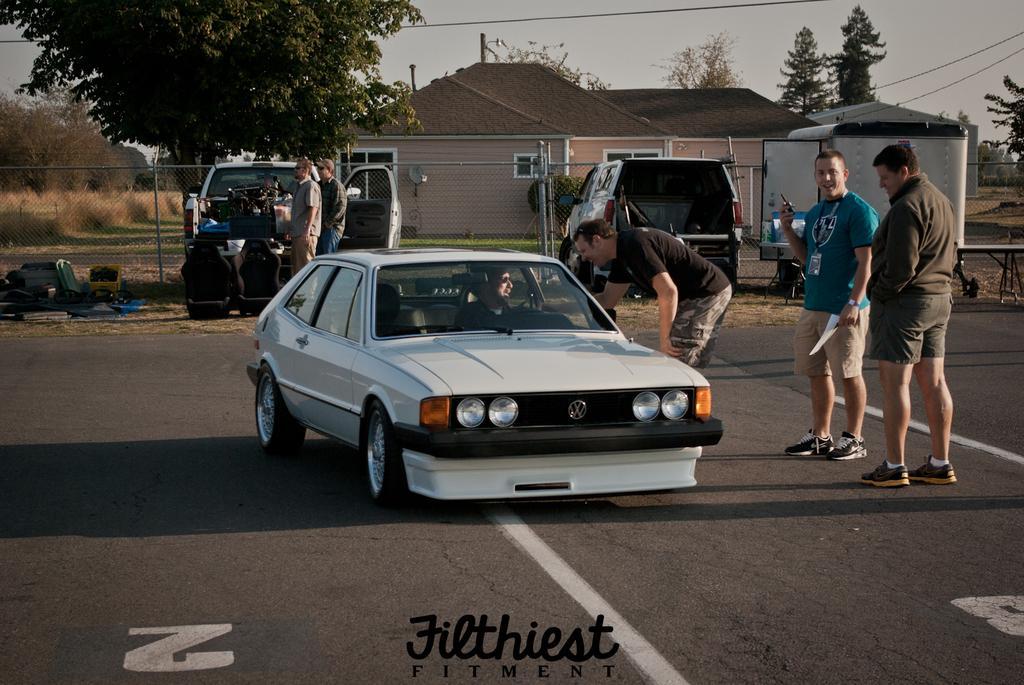How would you summarize this image in a sentence or two? In the foreground of the image we can see a car and a man sitting inside it. There are three people standing on the road. In the background of the image we can see a building, tree and a cargo. 